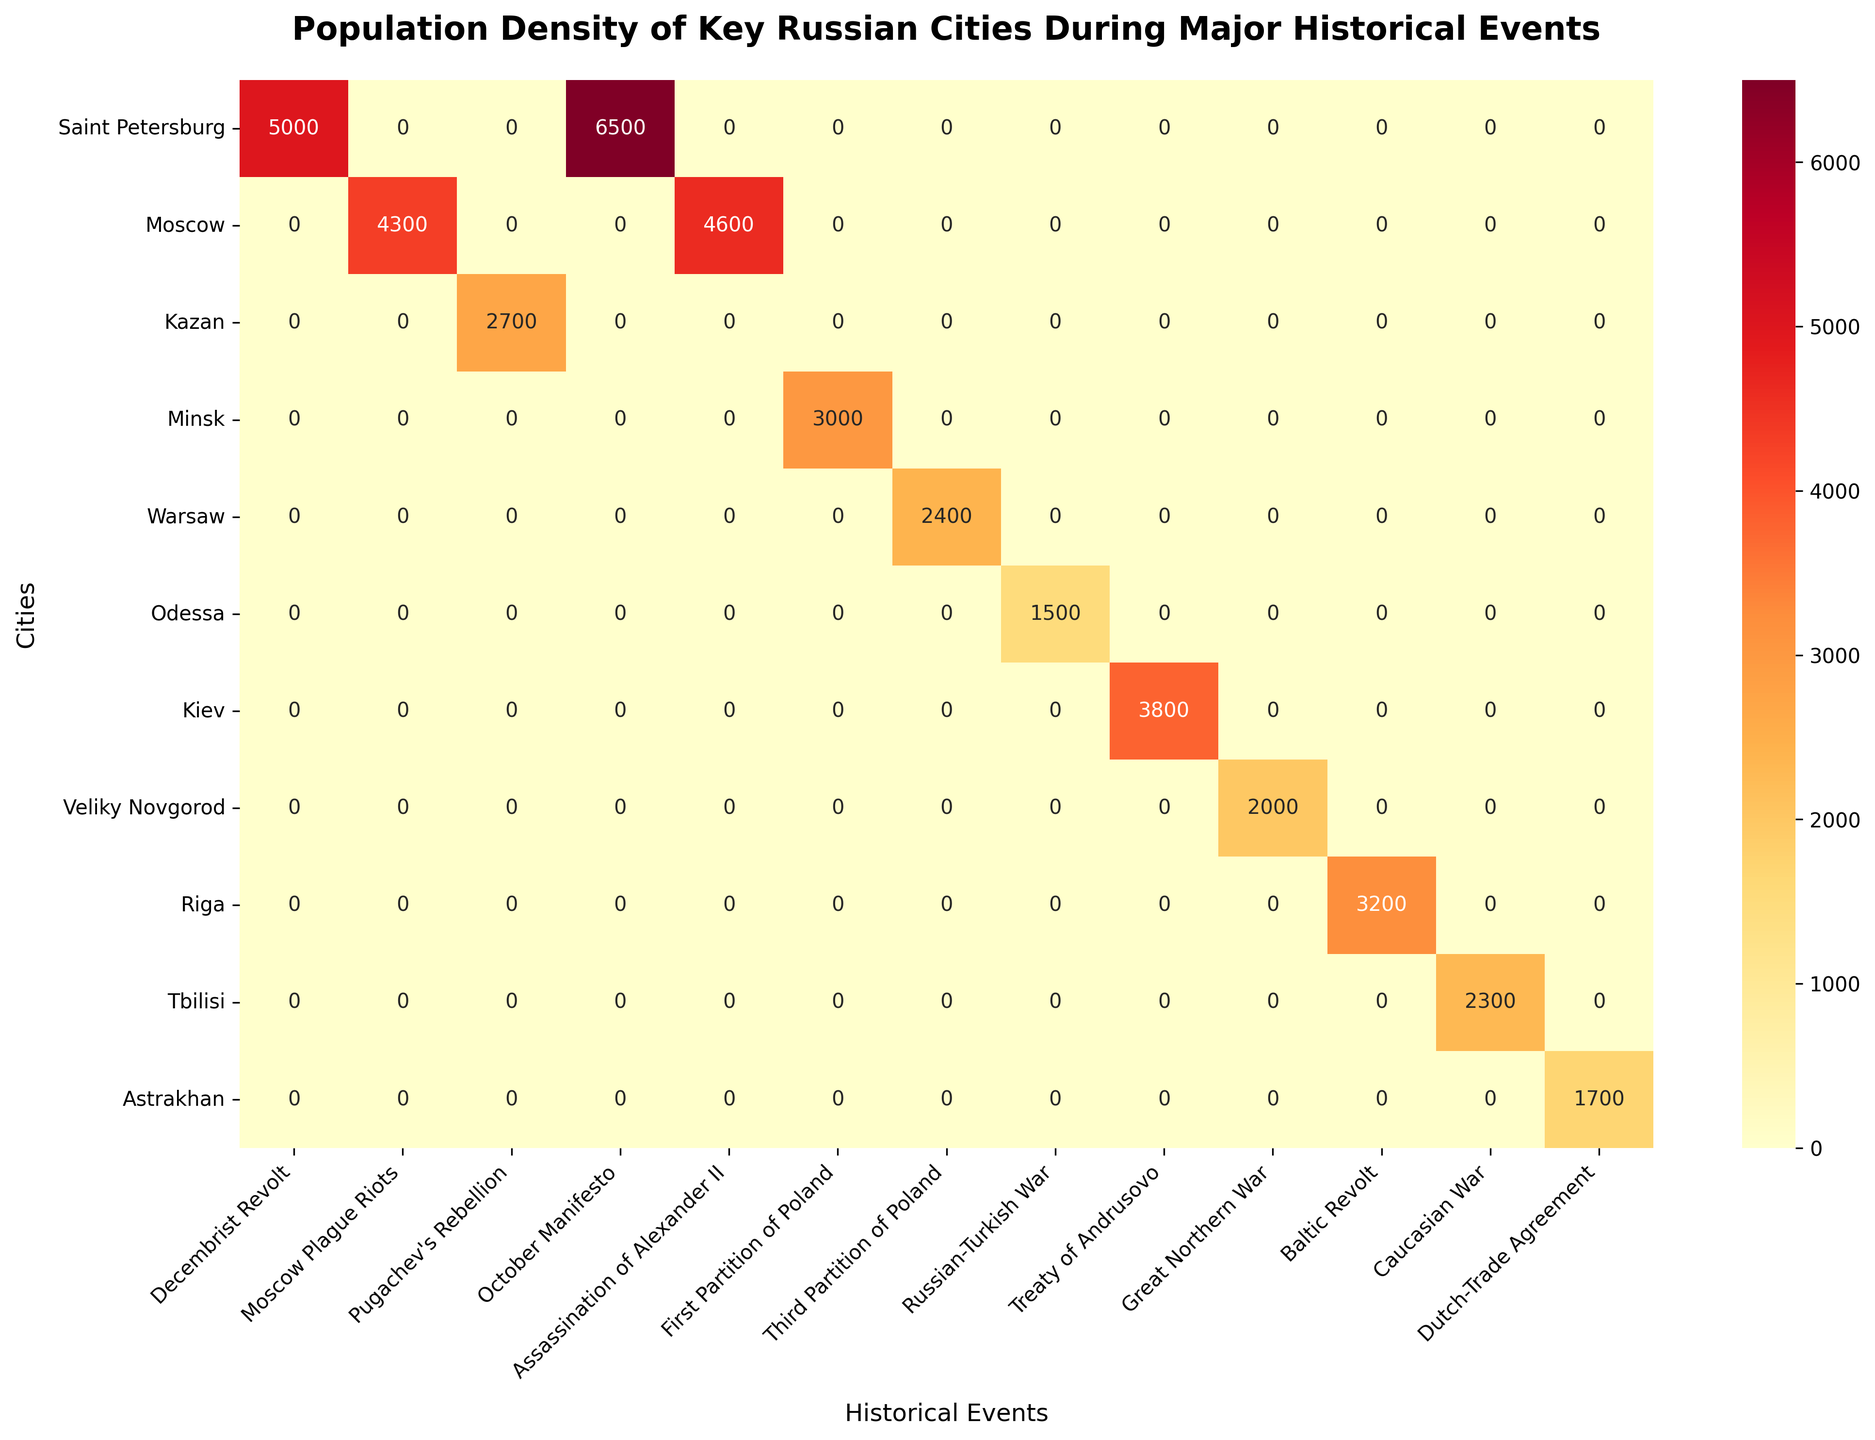what is the title of the heatmap? The title is located at the top of the figure and summarizes the purpose and scope of the plot.
Answer: Population Density of Key Russian Cities During Major Historical Events Which city had the highest population density during the October Manifesto? To find the answer, look for the October Manifesto column and identify the cell with the highest number. Compare the values across all cities.
Answer: Saint Petersburg What is the population density of Moscow during the Moscow Plague Riots? Locate the row for Moscow and the column for Moscow Plague Riots. The intersection of the row and column provides the value.
Answer: 4300 Which historical event had the lowest population density in Odessa? Locate the row for Odessa and compare all values in that row. Identify the event corresponding to the lowest number.
Answer: Russian-Turkish War What is the difference in population density between Kazan during Pugachev's Rebellion and Veliky Novgorod during the Great Northern War? Find the population densities for Kazan during Pugachev's Rebellion and Veliky Novgorod during the Great Northern War. Subtract the latter from the former.
Answer: 700 Which city had a higher population density during the assassination of Alexander II, Moscow or Riga? Look for the values corresponding to Moscow and Riga during the assassination of Alexander II. Compare the two values.
Answer: Moscow What is the average population density during the First Partition of Poland across all cities? Identify all population density values for the First Partition of Poland event. Sum these values and divide by the number of respective cities.
Answer: 3000 Which city's population density during the Caucasian War was closer to that of the Third Partition of Poland in Warsaw? Compare the population densities of Tbilisi during the Caucasian War and Warsaw during the Third Partition of Poland. Determine which one is numerically closer.
Answer: Tbilisi How many cities have a population density of over 4000 during any historical event? Identify all cells with values greater than 4000 and count the number of unique cities corresponding to these cells.
Answer: 4 